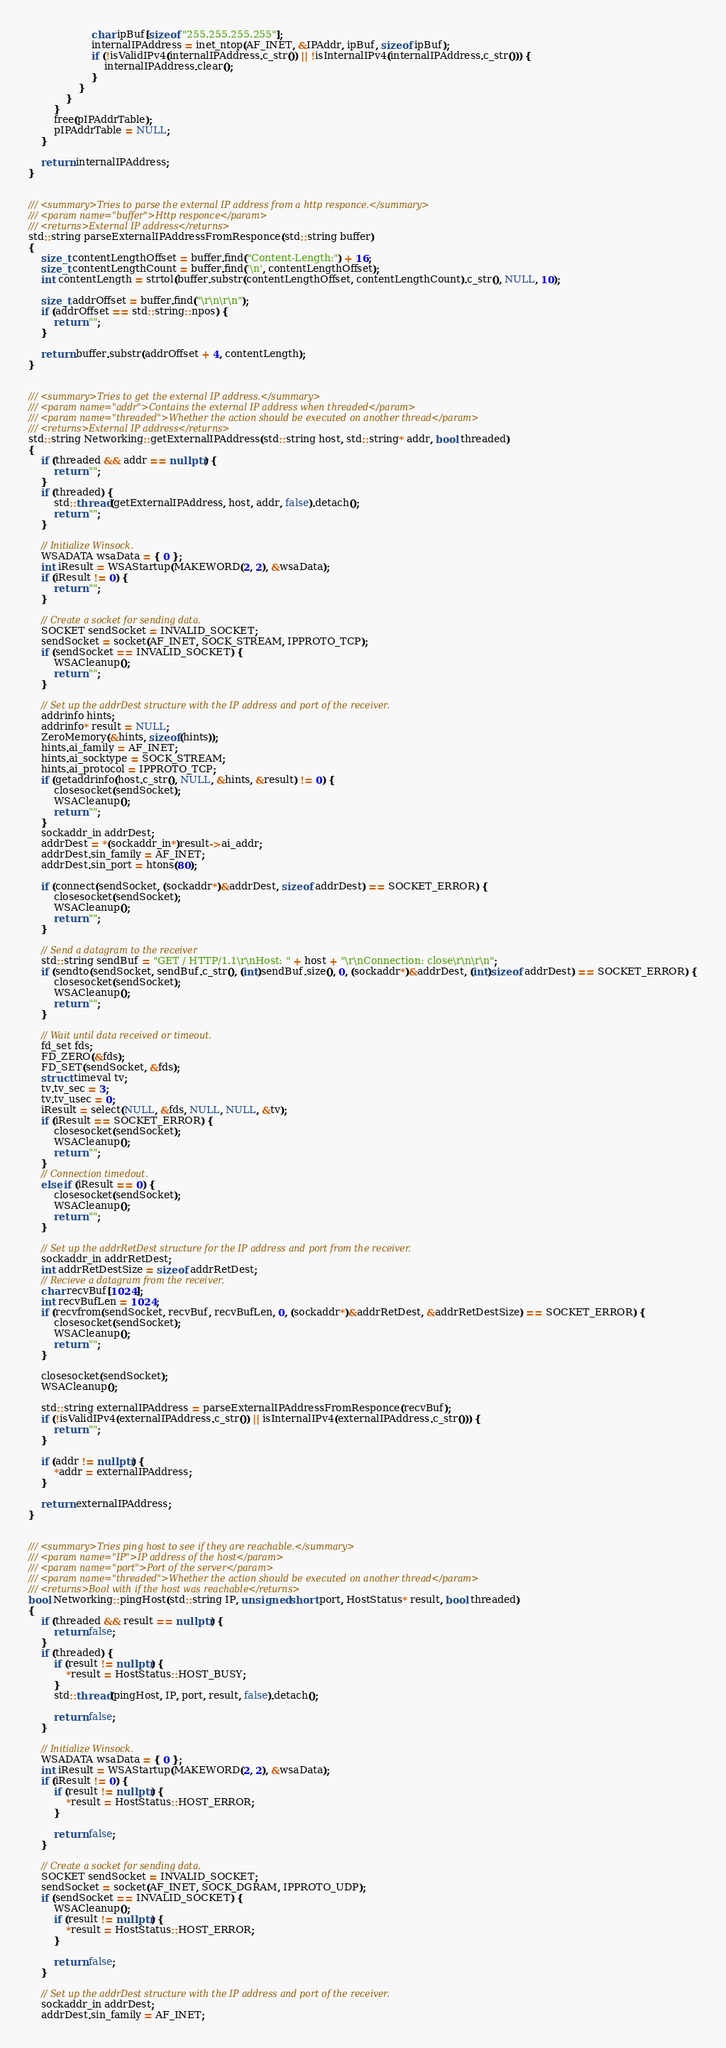Convert code to text. <code><loc_0><loc_0><loc_500><loc_500><_C++_>                    char ipBuf[sizeof "255.255.255.255"];
                    internalIPAddress = inet_ntop(AF_INET, &IPAddr, ipBuf, sizeof ipBuf);
                    if (!isValidIPv4(internalIPAddress.c_str()) || !isInternalIPv4(internalIPAddress.c_str())) {
                        internalIPAddress.clear();
                    }
                }
            }
        }
        free(pIPAddrTable);
        pIPAddrTable = NULL;
    }

    return internalIPAddress;
}


/// <summary>Tries to parse the external IP address from a http responce.</summary>
/// <param name="buffer">Http responce</param>
/// <returns>External IP address</returns>
std::string parseExternalIPAddressFromResponce(std::string buffer)
{
    size_t contentLengthOffset = buffer.find("Content-Length:") + 16;
    size_t contentLengthCount = buffer.find('\n', contentLengthOffset);
    int contentLength = strtol(buffer.substr(contentLengthOffset, contentLengthCount).c_str(), NULL, 10);

    size_t addrOffset = buffer.find("\r\n\r\n");
    if (addrOffset == std::string::npos) {
        return "";
    }

    return buffer.substr(addrOffset + 4, contentLength);
}


/// <summary>Tries to get the external IP address.</summary>
/// <param name="addr">Contains the external IP address when threaded</param>
/// <param name="threaded">Whether the action should be executed on another thread</param>
/// <returns>External IP address</returns>
std::string Networking::getExternalIPAddress(std::string host, std::string* addr, bool threaded)
{
    if (threaded && addr == nullptr) {
        return "";
    }
    if (threaded) {
        std::thread(getExternalIPAddress, host, addr, false).detach();
        return "";
    }

    // Initialize Winsock.
    WSADATA wsaData = { 0 };
    int iResult = WSAStartup(MAKEWORD(2, 2), &wsaData);
    if (iResult != 0) {
        return "";
    }

    // Create a socket for sending data.
    SOCKET sendSocket = INVALID_SOCKET;
    sendSocket = socket(AF_INET, SOCK_STREAM, IPPROTO_TCP);
    if (sendSocket == INVALID_SOCKET) {
        WSACleanup();
        return "";
    }

    // Set up the addrDest structure with the IP address and port of the receiver.
    addrinfo hints;
    addrinfo* result = NULL;
    ZeroMemory(&hints, sizeof(hints));
    hints.ai_family = AF_INET;
    hints.ai_socktype = SOCK_STREAM;
    hints.ai_protocol = IPPROTO_TCP;
    if (getaddrinfo(host.c_str(), NULL, &hints, &result) != 0) {
        closesocket(sendSocket);
        WSACleanup();
        return "";
    }
    sockaddr_in addrDest;
    addrDest = *(sockaddr_in*)result->ai_addr;
    addrDest.sin_family = AF_INET;
    addrDest.sin_port = htons(80);

    if (connect(sendSocket, (sockaddr*)&addrDest, sizeof addrDest) == SOCKET_ERROR) {
        closesocket(sendSocket);
        WSACleanup();
        return "";
    }

    // Send a datagram to the receiver
    std::string sendBuf = "GET / HTTP/1.1\r\nHost: " + host + "\r\nConnection: close\r\n\r\n";
    if (sendto(sendSocket, sendBuf.c_str(), (int)sendBuf.size(), 0, (sockaddr*)&addrDest, (int)sizeof addrDest) == SOCKET_ERROR) {
        closesocket(sendSocket);
        WSACleanup();
        return "";
    }

    // Wait until data received or timeout.
    fd_set fds;
    FD_ZERO(&fds);
    FD_SET(sendSocket, &fds);
    struct timeval tv;
    tv.tv_sec = 3;
    tv.tv_usec = 0;
    iResult = select(NULL, &fds, NULL, NULL, &tv);
    if (iResult == SOCKET_ERROR) {
        closesocket(sendSocket);
        WSACleanup();
        return "";
    }
    // Connection timedout.
    else if (iResult == 0) {
        closesocket(sendSocket);
        WSACleanup();
        return "";
    }

    // Set up the addrRetDest structure for the IP address and port from the receiver.
    sockaddr_in addrRetDest;
    int addrRetDestSize = sizeof addrRetDest;
    // Recieve a datagram from the receiver.
    char recvBuf[1024];
    int recvBufLen = 1024;
    if (recvfrom(sendSocket, recvBuf, recvBufLen, 0, (sockaddr*)&addrRetDest, &addrRetDestSize) == SOCKET_ERROR) {
        closesocket(sendSocket);
        WSACleanup();
        return "";
    }

    closesocket(sendSocket);
    WSACleanup();

    std::string externalIPAddress = parseExternalIPAddressFromResponce(recvBuf);
    if (!isValidIPv4(externalIPAddress.c_str()) || isInternalIPv4(externalIPAddress.c_str())) {
        return "";
    }

    if (addr != nullptr) {
        *addr = externalIPAddress;
    }

    return externalIPAddress;
}


/// <summary>Tries ping host to see if they are reachable.</summary>
/// <param name="IP">IP address of the host</param>
/// <param name="port">Port of the server</param>
/// <param name="threaded">Whether the action should be executed on another thread</param>
/// <returns>Bool with if the host was reachable</returns>
bool Networking::pingHost(std::string IP, unsigned short port, HostStatus* result, bool threaded)
{
    if (threaded && result == nullptr) {
        return false;
    }
    if (threaded) {
        if (result != nullptr) {
            *result = HostStatus::HOST_BUSY;
        }
        std::thread(pingHost, IP, port, result, false).detach();

        return false;
    }

    // Initialize Winsock.
    WSADATA wsaData = { 0 };
    int iResult = WSAStartup(MAKEWORD(2, 2), &wsaData);
    if (iResult != 0) {
        if (result != nullptr) {
            *result = HostStatus::HOST_ERROR;
        }

        return false;
    }

    // Create a socket for sending data.
    SOCKET sendSocket = INVALID_SOCKET;
    sendSocket = socket(AF_INET, SOCK_DGRAM, IPPROTO_UDP);
    if (sendSocket == INVALID_SOCKET) {
        WSACleanup();
        if (result != nullptr) {
            *result = HostStatus::HOST_ERROR;
        }

        return false;
    }

    // Set up the addrDest structure with the IP address and port of the receiver.
    sockaddr_in addrDest;
    addrDest.sin_family = AF_INET;</code> 